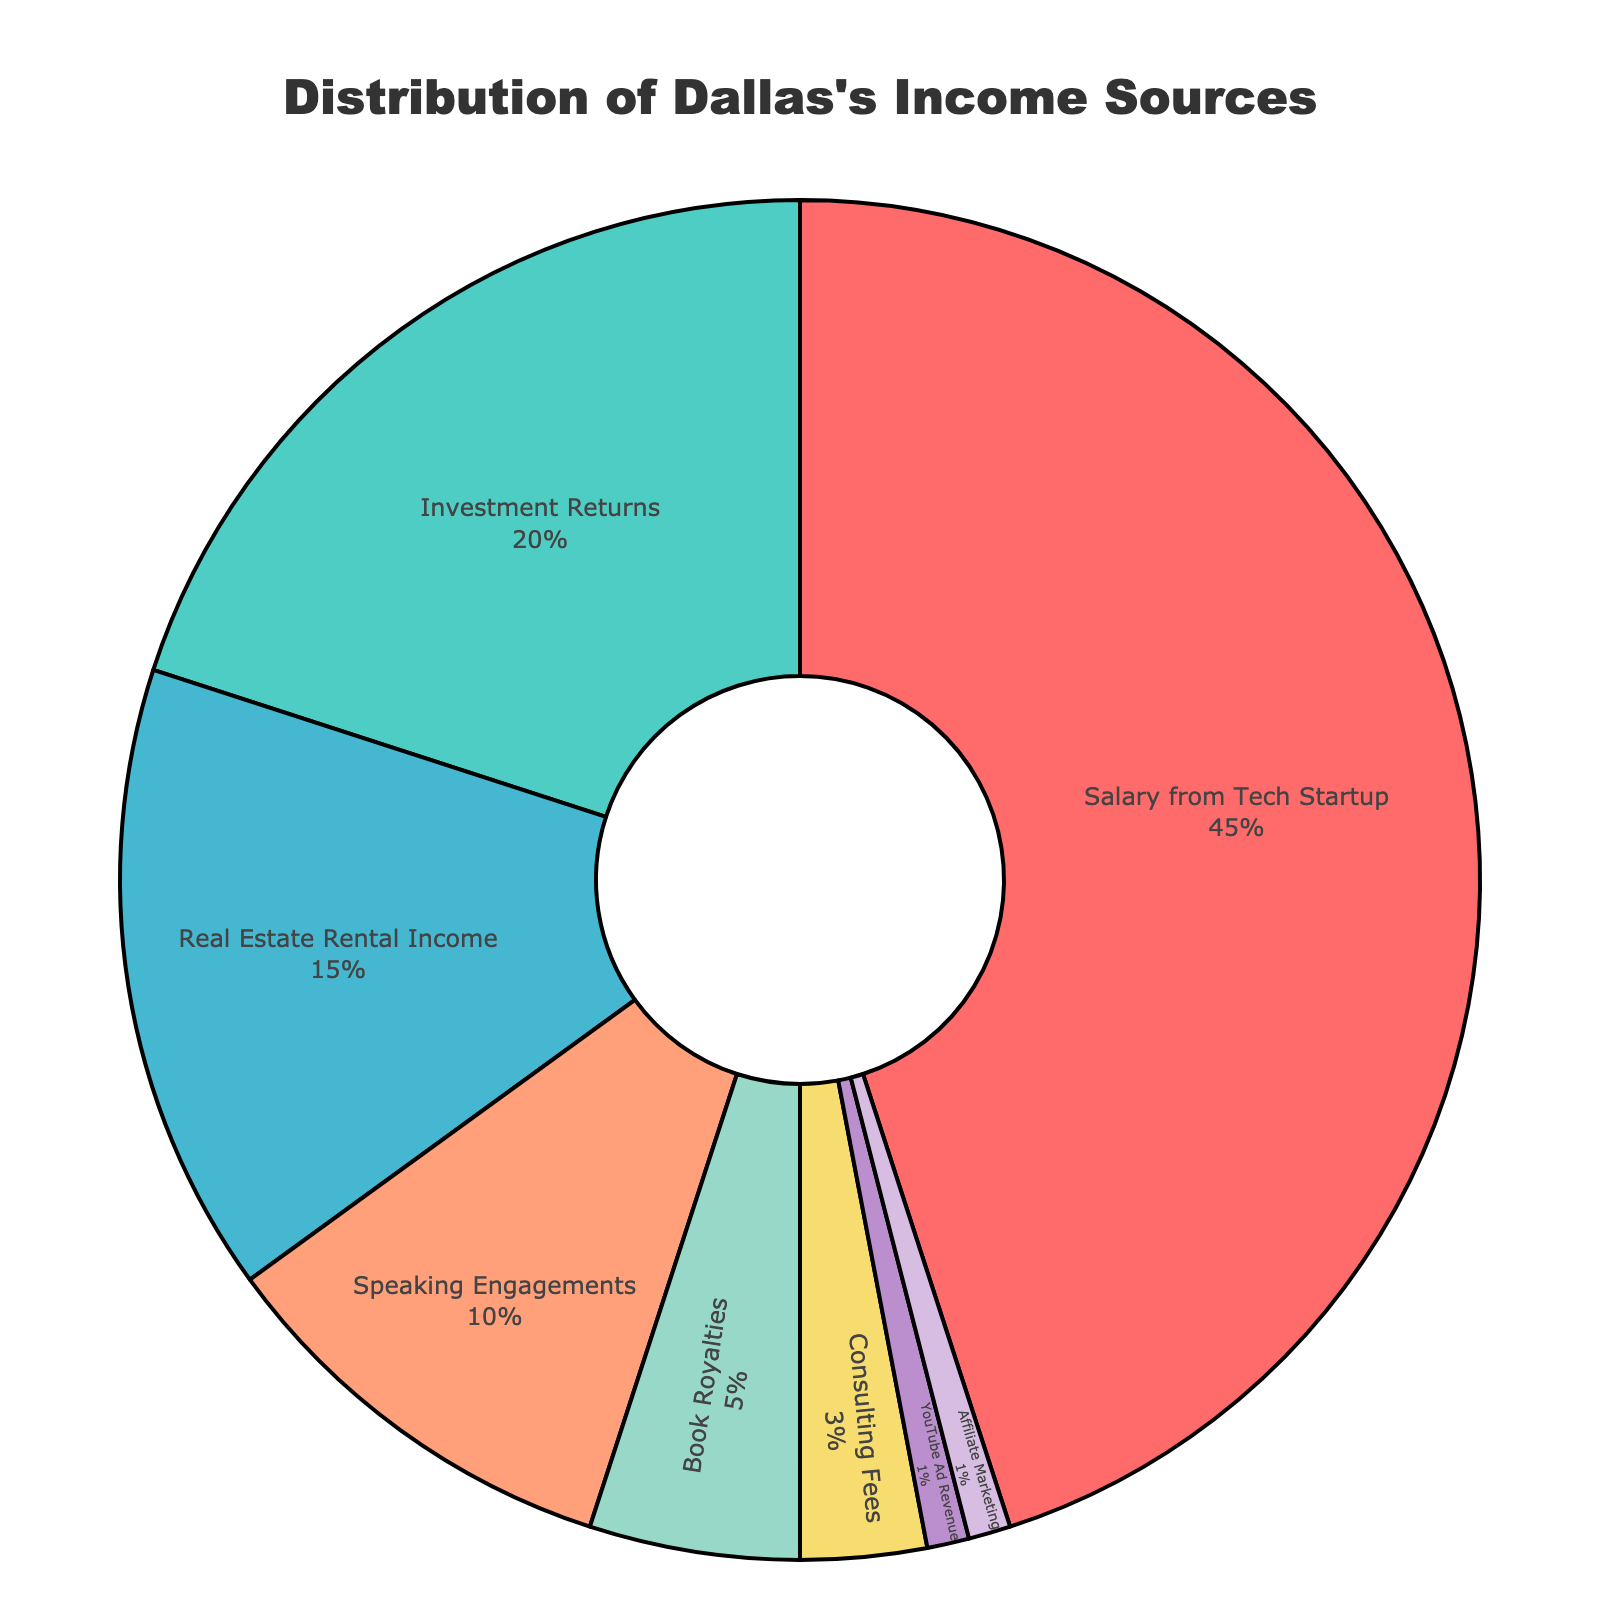What is the largest portion of Dallas's income? The largest portion is represented by the biggest segment in the pie chart. Referring to the figure, it is "Salary from Tech Startup" which occupies 45% of the pie.
Answer: Salary from Tech Startup What percentage of Dallas’s income comes from non-investment sources? To find the non-investment sources, sum the percentages of all sources excluding "Investment Returns." The non-investment sources are "Salary from Tech Startup" (45%), "Real Estate Rental Income" (15%), "Speaking Engagements" (10%), "Book Royalties" (5%), "Consulting Fees" (3%), "YouTube Ad Revenue" (1%), and "Affiliate Marketing" (1%). The total is 45 + 15 + 10 + 5 + 3 + 1 + 1 = 80%.
Answer: 80% How much more does Dallas earn from his Salary compared to Real Estate Rental Income? Subtract the percentage of Real Estate Rental Income from the Salary percentage. It is calculated as 45% (Salary from Tech Startup) - 15% (Real Estate Rental Income) = 30%.
Answer: 30% Which two sources make up a quarter of Dallas's income? Identify two sources whose combined percentages equal roughly 25%. "Investment Returns" (20%) and "Affiliate Marketing" (1%) plus "YouTube Ad Revenue" (1%) plus "Consulting Fees" (3%) equals 20% + 1% + 1% + 3% = 25%.
Answer: Investment Returns and Consulting Fees + Affiliate Marketing + YouTube Ad Revenue What is the second smallest income source for Dallas? Refer to the pie chart to find the second smallest segment. The smallest is "Affiliate Marketing" and "YouTube Ad Revenue" each at 1%. The next smallest is "Consulting Fees" at 3%.
Answer: Consulting Fees What is the difference between the income from Speaking Engagements and Book Royalties? Subtract the percentage of Book Royalties income from Speaking Engagements. It is calculated as 10% (Speaking Engagements) - 5% (Book Royalties) = 5%.
Answer: 5% Which income source combination forms approximately half of the total income? Identify combinations that add up to approximately 50%. "Salary from Tech Startup" is 45%, and "Affiliate Marketing" (1%) + "YouTube Ad Revenue" (1%) + "Consulting Fees" (3%) is 5%. Together, they make 45% + 5% = 50%.
Answer: Salary from Tech Startup + Affiliate Marketing + YouTube Ad Revenue + Consulting Fees What's the sum of percentages for the income sources that contribute less than 10% each? Add the percentages of all income sources contributing less than 10%. These are "Book Royalties" (5%), "Consulting Fees" (3%), "YouTube Ad Revenue" (1%), and "Affiliate Marketing" (1%). The total is 5 + 3 + 1 + 1 = 10%.
Answer: 10% From which income source does Dallas earn more: Consulting Fees or Real Estate Rental Income? Compare the percentages of "Consulting Fees" and "Real Estate Rental Income." Consulting Fees contribute 3%, while Real Estate Rental Income is 15%.
Answer: Real Estate Rental Income 